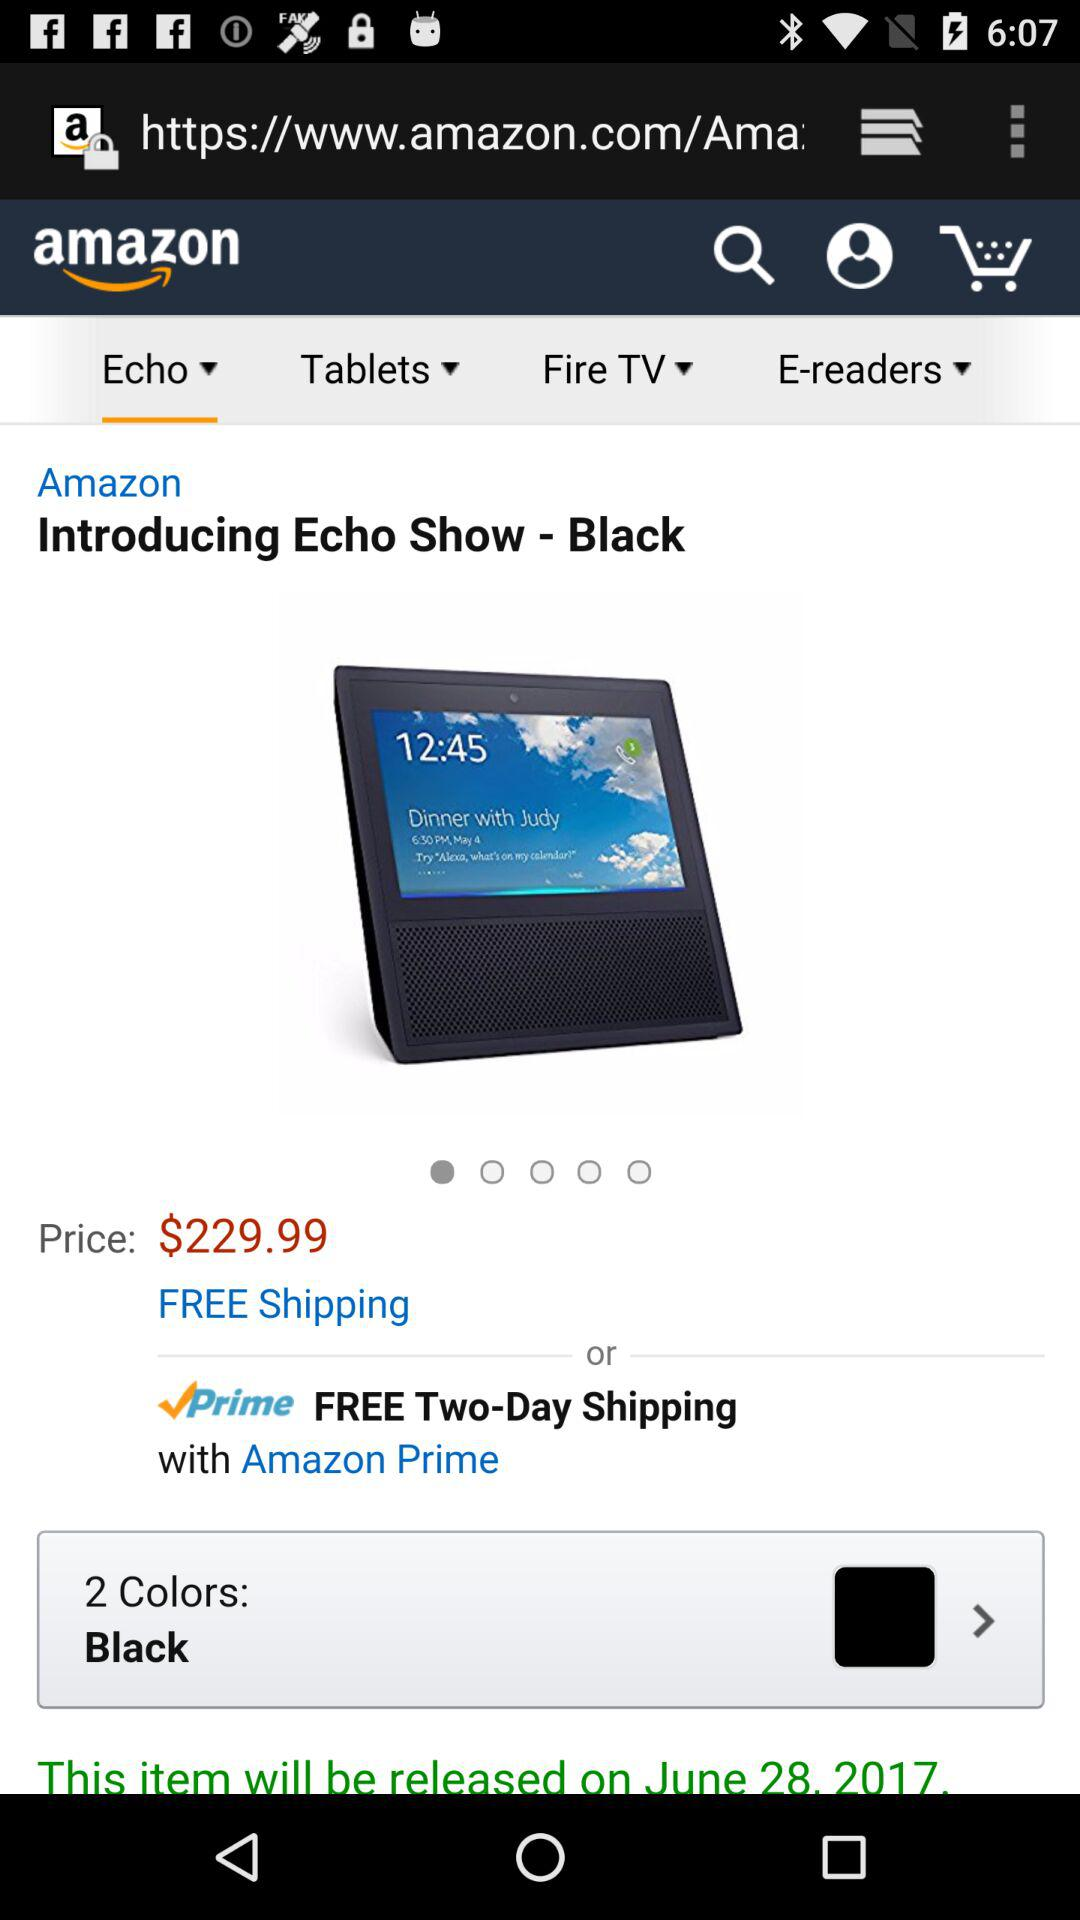How many colors are available? There are 2 colors available. 